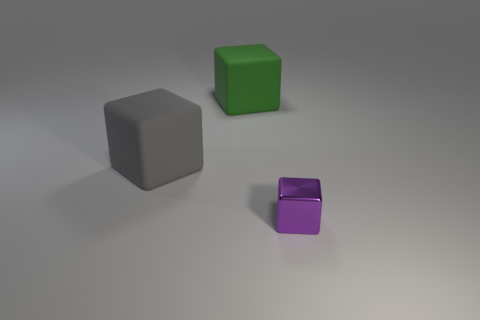Is the large green object the same shape as the big gray object?
Offer a very short reply. Yes. How big is the object in front of the big gray matte block?
Ensure brevity in your answer.  Small. There is a gray rubber object; is its size the same as the block that is to the right of the green thing?
Your answer should be very brief. No. Are there fewer big green cubes that are in front of the small shiny cube than small things?
Your answer should be compact. Yes. What is the material of the gray thing that is the same shape as the large green object?
Make the answer very short. Rubber. There is a thing that is to the right of the big gray object and behind the metallic object; what is its shape?
Provide a short and direct response. Cube. There is another object that is the same material as the big gray thing; what shape is it?
Keep it short and to the point. Cube. There is a big cube that is on the left side of the big green matte thing; what is its material?
Your response must be concise. Rubber. Do the metallic object that is right of the green object and the object to the left of the large green object have the same size?
Give a very brief answer. No. The tiny block has what color?
Offer a very short reply. Purple. 